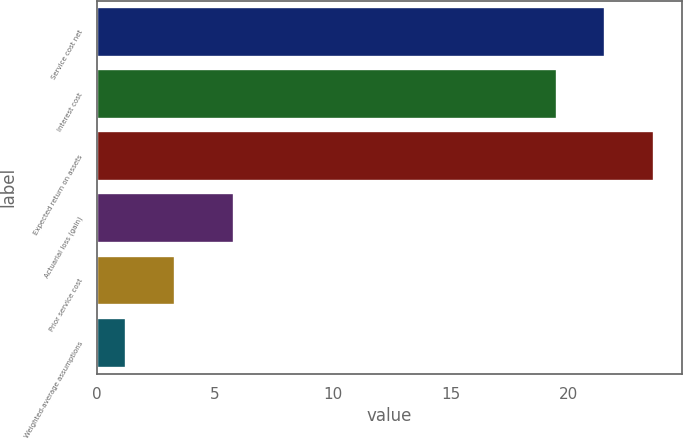Convert chart. <chart><loc_0><loc_0><loc_500><loc_500><bar_chart><fcel>Service cost net<fcel>Interest cost<fcel>Expected return on assets<fcel>Actuarial loss (gain)<fcel>Prior service cost<fcel>Weighted-average assumptions<nl><fcel>21.57<fcel>19.5<fcel>23.64<fcel>5.8<fcel>3.31<fcel>1.25<nl></chart> 